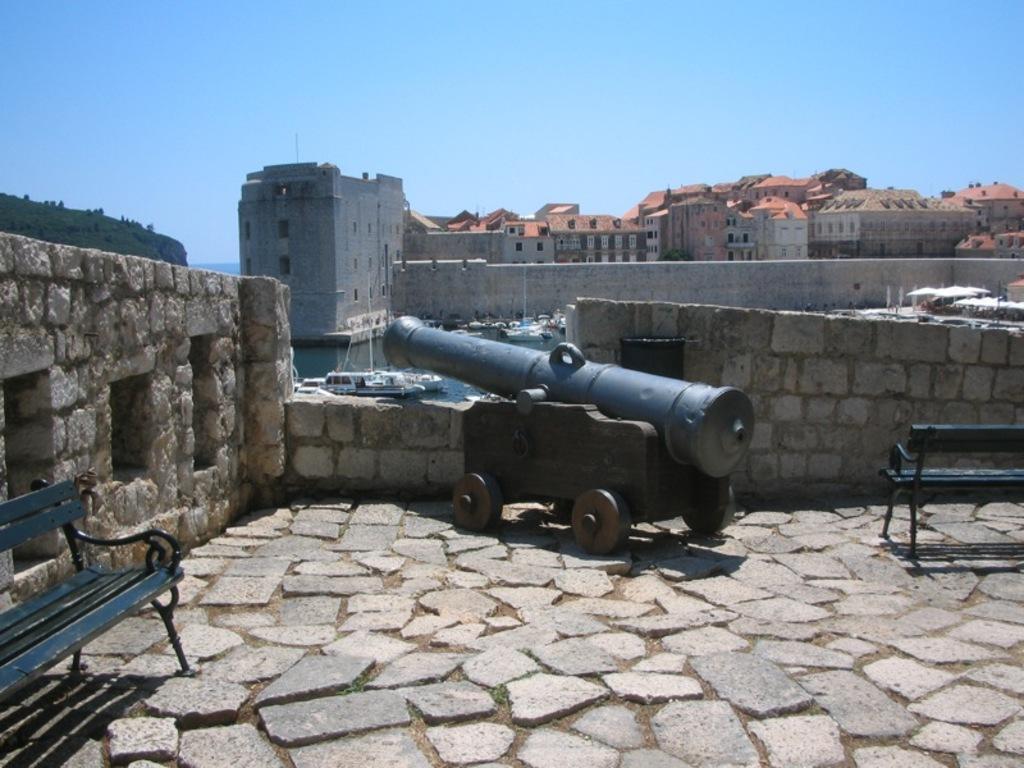Could you give a brief overview of what you see in this image? In this image, we can see a cannon. We can see the ground and the wall. We can see some boats sailing on the water. We can see some buildings and benches. We can see an object on the left. 